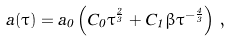Convert formula to latex. <formula><loc_0><loc_0><loc_500><loc_500>a ( \tau ) = a _ { 0 } \left ( C _ { 0 } \tau ^ { \frac { 2 } { 3 } } + C _ { 1 } \beta \tau ^ { - \frac { 4 } { 3 } } \right ) \, ,</formula> 